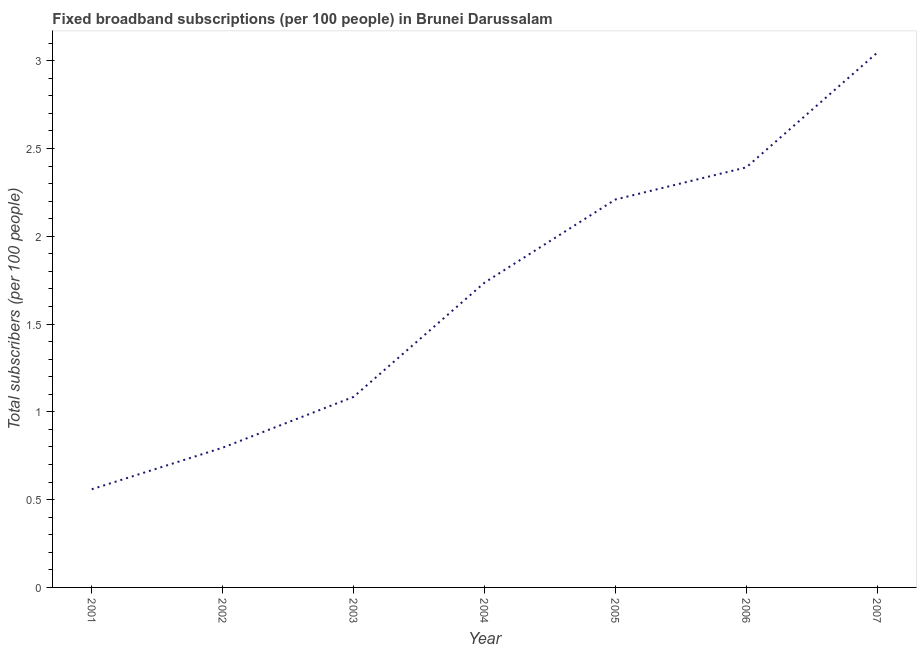What is the total number of fixed broadband subscriptions in 2006?
Your answer should be very brief. 2.39. Across all years, what is the maximum total number of fixed broadband subscriptions?
Give a very brief answer. 3.05. Across all years, what is the minimum total number of fixed broadband subscriptions?
Offer a very short reply. 0.56. In which year was the total number of fixed broadband subscriptions maximum?
Give a very brief answer. 2007. What is the sum of the total number of fixed broadband subscriptions?
Provide a short and direct response. 11.82. What is the difference between the total number of fixed broadband subscriptions in 2001 and 2007?
Give a very brief answer. -2.49. What is the average total number of fixed broadband subscriptions per year?
Offer a very short reply. 1.69. What is the median total number of fixed broadband subscriptions?
Give a very brief answer. 1.74. What is the ratio of the total number of fixed broadband subscriptions in 2005 to that in 2007?
Ensure brevity in your answer.  0.73. What is the difference between the highest and the second highest total number of fixed broadband subscriptions?
Keep it short and to the point. 0.65. What is the difference between the highest and the lowest total number of fixed broadband subscriptions?
Provide a short and direct response. 2.49. Does the total number of fixed broadband subscriptions monotonically increase over the years?
Provide a short and direct response. Yes. What is the difference between two consecutive major ticks on the Y-axis?
Provide a short and direct response. 0.5. Are the values on the major ticks of Y-axis written in scientific E-notation?
Offer a terse response. No. What is the title of the graph?
Your answer should be very brief. Fixed broadband subscriptions (per 100 people) in Brunei Darussalam. What is the label or title of the X-axis?
Make the answer very short. Year. What is the label or title of the Y-axis?
Offer a terse response. Total subscribers (per 100 people). What is the Total subscribers (per 100 people) of 2001?
Offer a very short reply. 0.56. What is the Total subscribers (per 100 people) of 2002?
Make the answer very short. 0.8. What is the Total subscribers (per 100 people) in 2003?
Ensure brevity in your answer.  1.09. What is the Total subscribers (per 100 people) in 2004?
Provide a short and direct response. 1.74. What is the Total subscribers (per 100 people) of 2005?
Keep it short and to the point. 2.21. What is the Total subscribers (per 100 people) in 2006?
Ensure brevity in your answer.  2.39. What is the Total subscribers (per 100 people) in 2007?
Provide a succinct answer. 3.05. What is the difference between the Total subscribers (per 100 people) in 2001 and 2002?
Give a very brief answer. -0.24. What is the difference between the Total subscribers (per 100 people) in 2001 and 2003?
Provide a succinct answer. -0.53. What is the difference between the Total subscribers (per 100 people) in 2001 and 2004?
Give a very brief answer. -1.18. What is the difference between the Total subscribers (per 100 people) in 2001 and 2005?
Provide a short and direct response. -1.65. What is the difference between the Total subscribers (per 100 people) in 2001 and 2006?
Keep it short and to the point. -1.83. What is the difference between the Total subscribers (per 100 people) in 2001 and 2007?
Provide a succinct answer. -2.49. What is the difference between the Total subscribers (per 100 people) in 2002 and 2003?
Your answer should be very brief. -0.29. What is the difference between the Total subscribers (per 100 people) in 2002 and 2004?
Your answer should be compact. -0.94. What is the difference between the Total subscribers (per 100 people) in 2002 and 2005?
Provide a succinct answer. -1.41. What is the difference between the Total subscribers (per 100 people) in 2002 and 2006?
Your answer should be compact. -1.6. What is the difference between the Total subscribers (per 100 people) in 2002 and 2007?
Your answer should be compact. -2.25. What is the difference between the Total subscribers (per 100 people) in 2003 and 2004?
Provide a short and direct response. -0.65. What is the difference between the Total subscribers (per 100 people) in 2003 and 2005?
Make the answer very short. -1.12. What is the difference between the Total subscribers (per 100 people) in 2003 and 2006?
Offer a very short reply. -1.31. What is the difference between the Total subscribers (per 100 people) in 2003 and 2007?
Provide a short and direct response. -1.96. What is the difference between the Total subscribers (per 100 people) in 2004 and 2005?
Offer a very short reply. -0.47. What is the difference between the Total subscribers (per 100 people) in 2004 and 2006?
Provide a short and direct response. -0.66. What is the difference between the Total subscribers (per 100 people) in 2004 and 2007?
Provide a short and direct response. -1.31. What is the difference between the Total subscribers (per 100 people) in 2005 and 2006?
Give a very brief answer. -0.18. What is the difference between the Total subscribers (per 100 people) in 2005 and 2007?
Provide a succinct answer. -0.84. What is the difference between the Total subscribers (per 100 people) in 2006 and 2007?
Provide a short and direct response. -0.65. What is the ratio of the Total subscribers (per 100 people) in 2001 to that in 2002?
Your response must be concise. 0.7. What is the ratio of the Total subscribers (per 100 people) in 2001 to that in 2003?
Make the answer very short. 0.52. What is the ratio of the Total subscribers (per 100 people) in 2001 to that in 2004?
Make the answer very short. 0.32. What is the ratio of the Total subscribers (per 100 people) in 2001 to that in 2005?
Make the answer very short. 0.25. What is the ratio of the Total subscribers (per 100 people) in 2001 to that in 2006?
Your answer should be very brief. 0.23. What is the ratio of the Total subscribers (per 100 people) in 2001 to that in 2007?
Provide a succinct answer. 0.18. What is the ratio of the Total subscribers (per 100 people) in 2002 to that in 2003?
Give a very brief answer. 0.73. What is the ratio of the Total subscribers (per 100 people) in 2002 to that in 2004?
Offer a very short reply. 0.46. What is the ratio of the Total subscribers (per 100 people) in 2002 to that in 2005?
Provide a succinct answer. 0.36. What is the ratio of the Total subscribers (per 100 people) in 2002 to that in 2006?
Your answer should be compact. 0.33. What is the ratio of the Total subscribers (per 100 people) in 2002 to that in 2007?
Provide a succinct answer. 0.26. What is the ratio of the Total subscribers (per 100 people) in 2003 to that in 2004?
Make the answer very short. 0.62. What is the ratio of the Total subscribers (per 100 people) in 2003 to that in 2005?
Make the answer very short. 0.49. What is the ratio of the Total subscribers (per 100 people) in 2003 to that in 2006?
Make the answer very short. 0.45. What is the ratio of the Total subscribers (per 100 people) in 2003 to that in 2007?
Provide a succinct answer. 0.36. What is the ratio of the Total subscribers (per 100 people) in 2004 to that in 2005?
Give a very brief answer. 0.79. What is the ratio of the Total subscribers (per 100 people) in 2004 to that in 2006?
Make the answer very short. 0.72. What is the ratio of the Total subscribers (per 100 people) in 2004 to that in 2007?
Give a very brief answer. 0.57. What is the ratio of the Total subscribers (per 100 people) in 2005 to that in 2006?
Give a very brief answer. 0.92. What is the ratio of the Total subscribers (per 100 people) in 2005 to that in 2007?
Keep it short and to the point. 0.72. What is the ratio of the Total subscribers (per 100 people) in 2006 to that in 2007?
Your answer should be very brief. 0.79. 